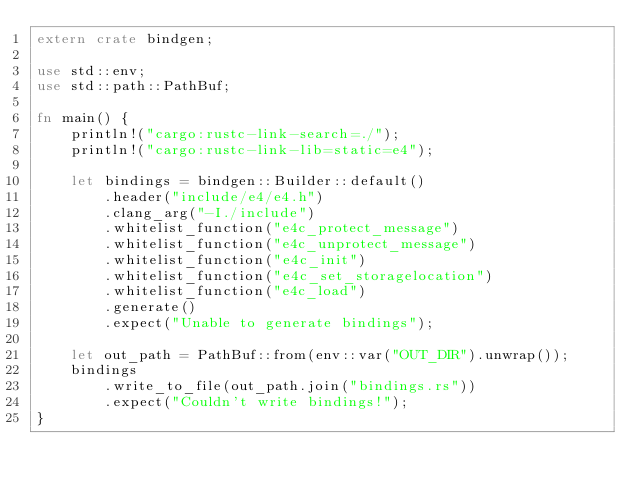Convert code to text. <code><loc_0><loc_0><loc_500><loc_500><_Rust_>extern crate bindgen;

use std::env;
use std::path::PathBuf;

fn main() {
    println!("cargo:rustc-link-search=./");
    println!("cargo:rustc-link-lib=static=e4");

    let bindings = bindgen::Builder::default()
        .header("include/e4/e4.h")
        .clang_arg("-I./include")
        .whitelist_function("e4c_protect_message")
        .whitelist_function("e4c_unprotect_message")
        .whitelist_function("e4c_init")
        .whitelist_function("e4c_set_storagelocation")
        .whitelist_function("e4c_load")
        .generate()
        .expect("Unable to generate bindings");

    let out_path = PathBuf::from(env::var("OUT_DIR").unwrap());
    bindings
        .write_to_file(out_path.join("bindings.rs"))
        .expect("Couldn't write bindings!");
}
</code> 